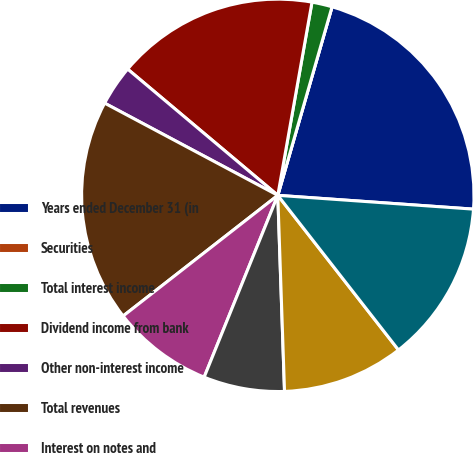Convert chart. <chart><loc_0><loc_0><loc_500><loc_500><pie_chart><fcel>Years ended December 31 (in<fcel>Securities<fcel>Total interest income<fcel>Dividend income from bank<fcel>Other non-interest income<fcel>Total revenues<fcel>Interest on notes and<fcel>Non-interest expense<fcel>Total expenses<fcel>Income before income tax<nl><fcel>21.66%<fcel>0.0%<fcel>1.67%<fcel>16.66%<fcel>3.34%<fcel>18.33%<fcel>8.33%<fcel>6.67%<fcel>10.0%<fcel>13.33%<nl></chart> 